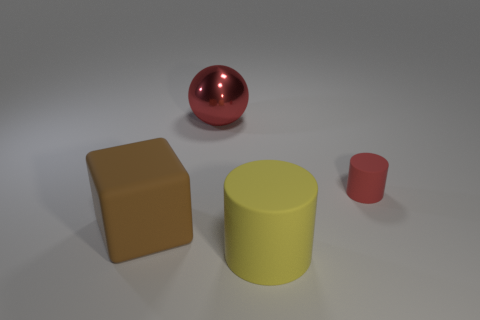There is a object that is behind the brown object and right of the large red shiny sphere; what color is it?
Give a very brief answer. Red. There is a red object that is left of the cylinder that is behind the big brown rubber thing; what is it made of?
Give a very brief answer. Metal. Does the block have the same size as the red shiny thing?
Your answer should be compact. Yes. How many big objects are red objects or brown objects?
Offer a very short reply. 2. There is a big cylinder; what number of rubber cylinders are right of it?
Give a very brief answer. 1. Is the number of large objects behind the big red metallic object greater than the number of objects?
Offer a terse response. No. What shape is the brown thing that is made of the same material as the tiny red object?
Offer a terse response. Cube. What color is the large matte thing that is to the left of the red thing that is to the left of the yellow rubber object?
Keep it short and to the point. Brown. Is the small rubber object the same shape as the yellow matte thing?
Keep it short and to the point. Yes. What is the material of the tiny object that is the same shape as the large yellow matte object?
Your response must be concise. Rubber. 